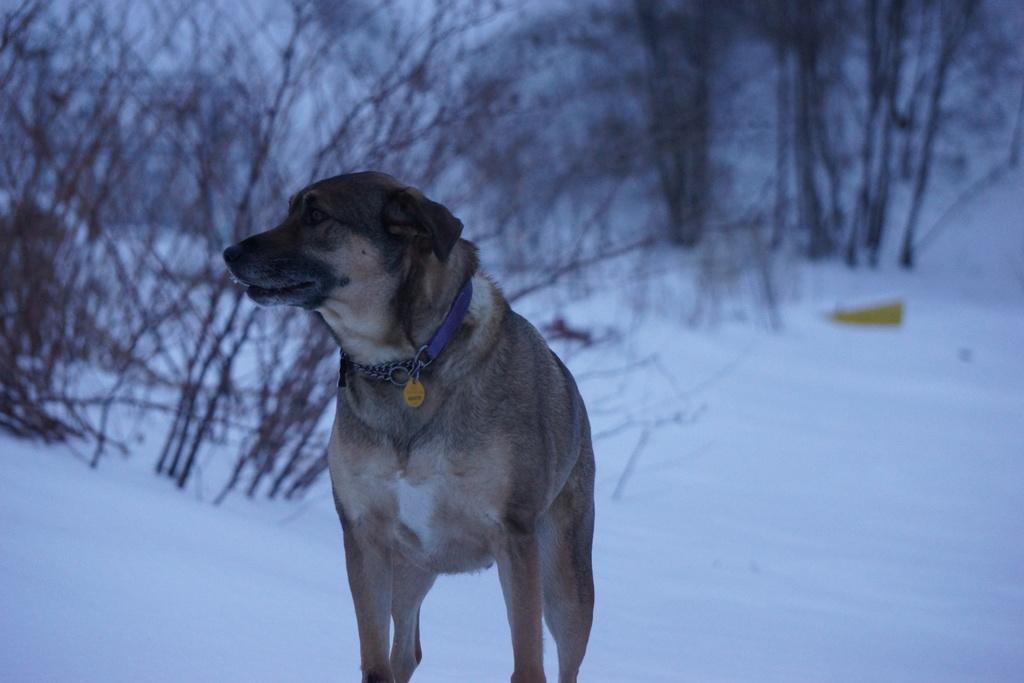Please provide a concise description of this image. In this image I can see a dog is standing and here I can see a blue colour belt. I can also see ground full of snow and number of trees. 